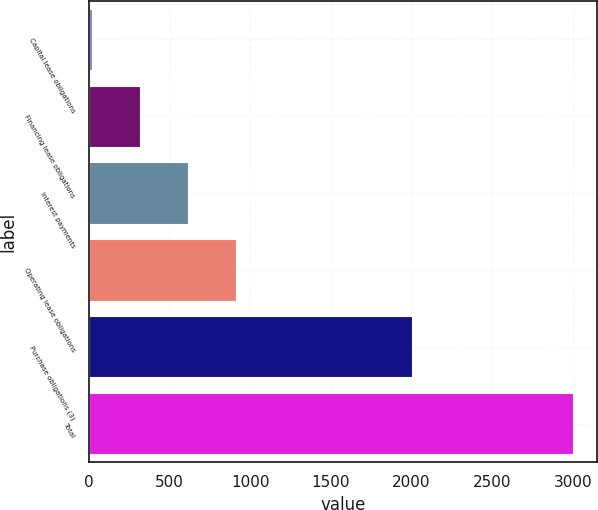Convert chart to OTSL. <chart><loc_0><loc_0><loc_500><loc_500><bar_chart><fcel>Capital lease obligations<fcel>Financing lease obligations<fcel>Interest payments<fcel>Operating lease obligations<fcel>Purchase obligations (3)<fcel>Total<nl><fcel>20<fcel>317.9<fcel>615.8<fcel>913.7<fcel>2004<fcel>2999<nl></chart> 